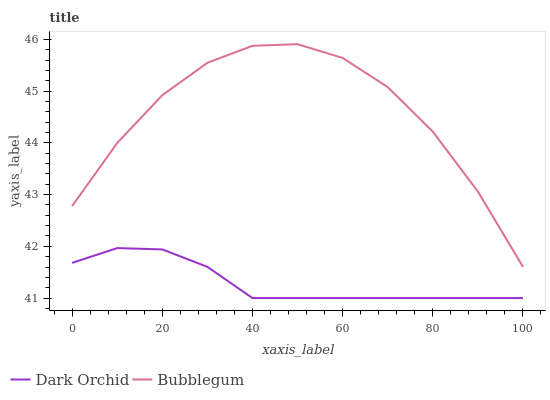Does Dark Orchid have the minimum area under the curve?
Answer yes or no. Yes. Does Bubblegum have the maximum area under the curve?
Answer yes or no. Yes. Does Dark Orchid have the maximum area under the curve?
Answer yes or no. No. Is Dark Orchid the smoothest?
Answer yes or no. Yes. Is Bubblegum the roughest?
Answer yes or no. Yes. Is Dark Orchid the roughest?
Answer yes or no. No. Does Dark Orchid have the lowest value?
Answer yes or no. Yes. Does Bubblegum have the highest value?
Answer yes or no. Yes. Does Dark Orchid have the highest value?
Answer yes or no. No. Is Dark Orchid less than Bubblegum?
Answer yes or no. Yes. Is Bubblegum greater than Dark Orchid?
Answer yes or no. Yes. Does Dark Orchid intersect Bubblegum?
Answer yes or no. No. 